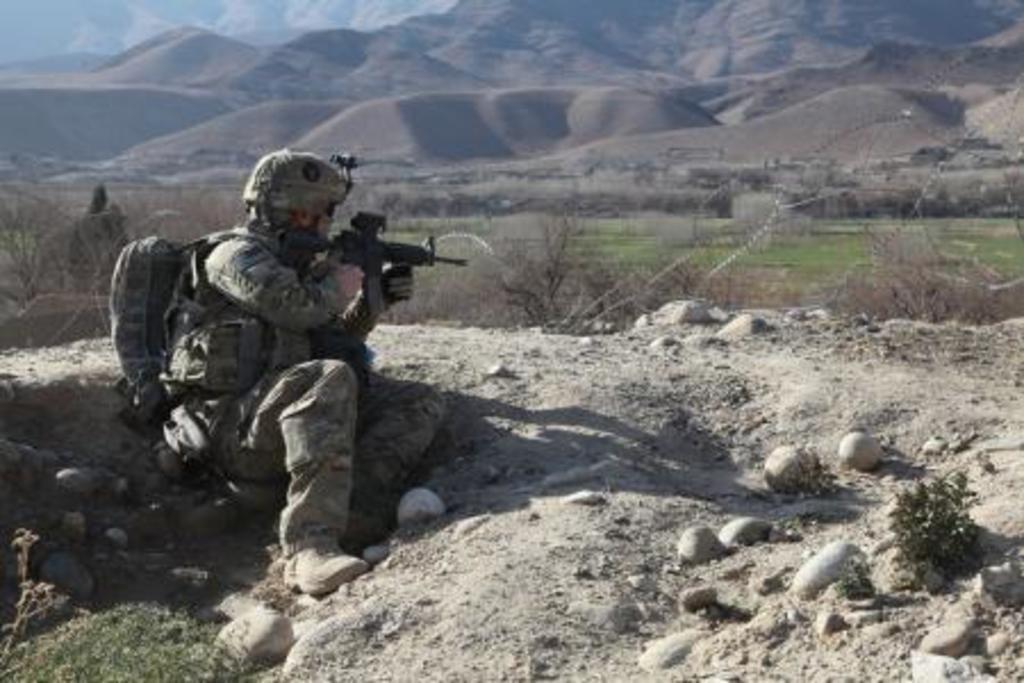Please provide a concise description of this image. In the picture I can see a man is sitting on the ground and holding a gun in hands. The man is wearing a uniform, a bag, a helmet and some other objects. In the background I can see trees, mountains, the sky and some other objects. 